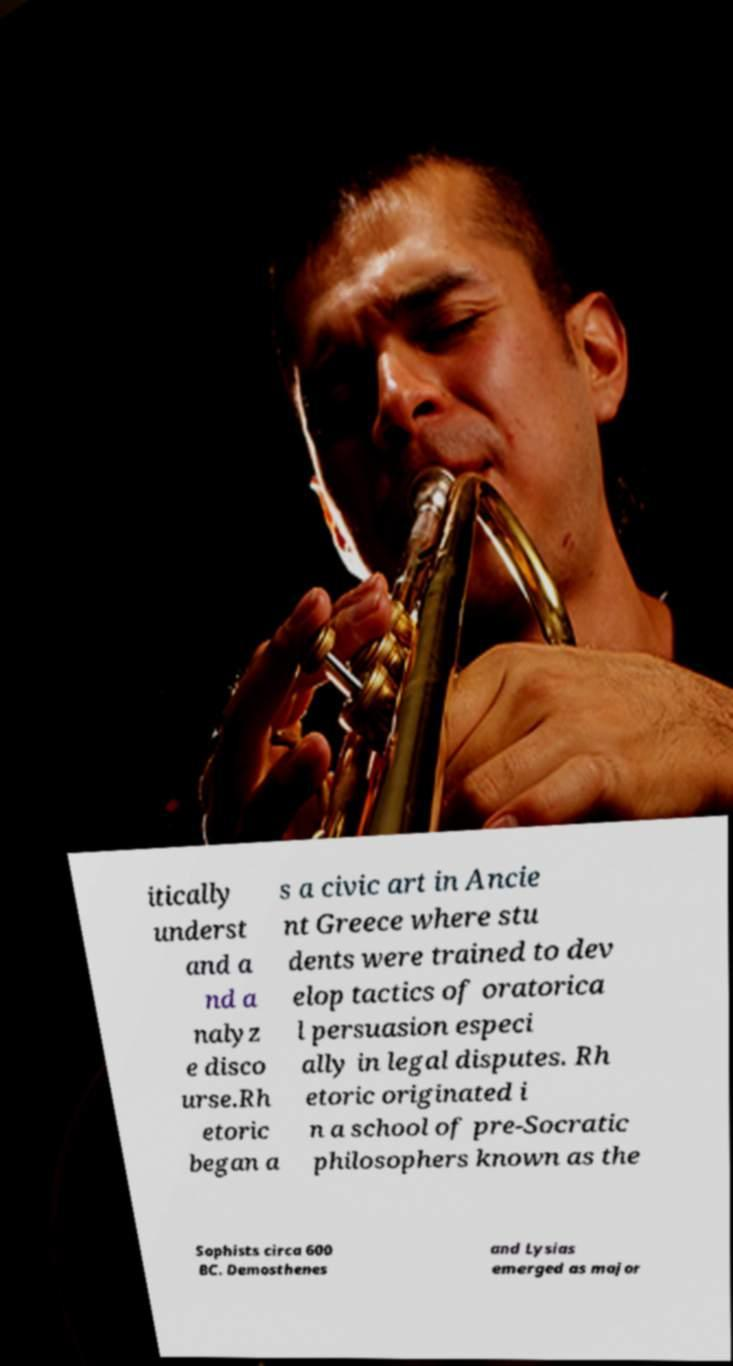Can you accurately transcribe the text from the provided image for me? itically underst and a nd a nalyz e disco urse.Rh etoric began a s a civic art in Ancie nt Greece where stu dents were trained to dev elop tactics of oratorica l persuasion especi ally in legal disputes. Rh etoric originated i n a school of pre-Socratic philosophers known as the Sophists circa 600 BC. Demosthenes and Lysias emerged as major 